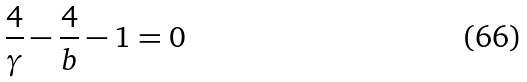<formula> <loc_0><loc_0><loc_500><loc_500>\frac { 4 } { \gamma } - \frac { 4 } { b } - 1 = 0</formula> 